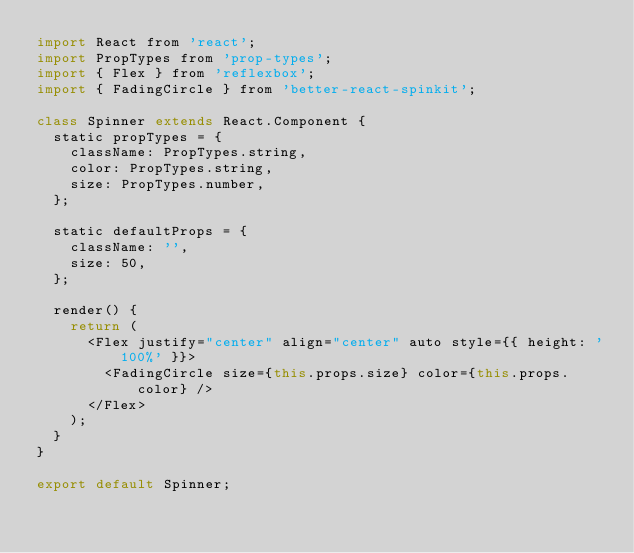Convert code to text. <code><loc_0><loc_0><loc_500><loc_500><_JavaScript_>import React from 'react';
import PropTypes from 'prop-types';
import { Flex } from 'reflexbox';
import { FadingCircle } from 'better-react-spinkit';

class Spinner extends React.Component {
  static propTypes = {
    className: PropTypes.string,
    color: PropTypes.string,
    size: PropTypes.number,
  };

  static defaultProps = {
    className: '',
    size: 50,
  };

  render() {
    return (
      <Flex justify="center" align="center" auto style={{ height: '100%' }}>
        <FadingCircle size={this.props.size} color={this.props.color} />
      </Flex>
    );
  }
}

export default Spinner;
</code> 